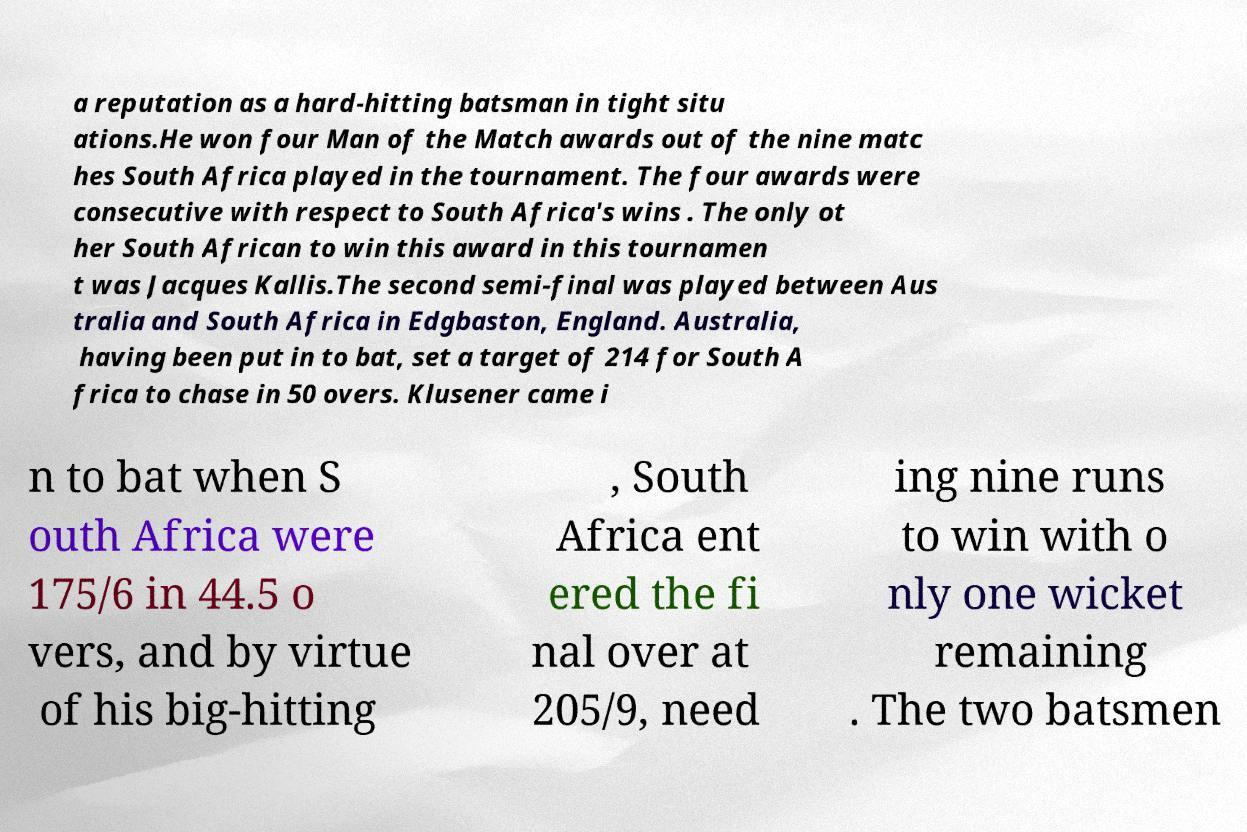Please identify and transcribe the text found in this image. a reputation as a hard-hitting batsman in tight situ ations.He won four Man of the Match awards out of the nine matc hes South Africa played in the tournament. The four awards were consecutive with respect to South Africa's wins . The only ot her South African to win this award in this tournamen t was Jacques Kallis.The second semi-final was played between Aus tralia and South Africa in Edgbaston, England. Australia, having been put in to bat, set a target of 214 for South A frica to chase in 50 overs. Klusener came i n to bat when S outh Africa were 175/6 in 44.5 o vers, and by virtue of his big-hitting , South Africa ent ered the fi nal over at 205/9, need ing nine runs to win with o nly one wicket remaining . The two batsmen 